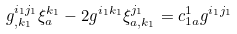Convert formula to latex. <formula><loc_0><loc_0><loc_500><loc_500>g ^ { i _ { 1 } j _ { 1 } } _ { , k _ { 1 } } \xi _ { a } ^ { k _ { 1 } } - 2 g ^ { i _ { 1 } k _ { 1 } } \xi _ { a , k _ { 1 } } ^ { j _ { 1 } } = c _ { 1 a } ^ { 1 } g ^ { i _ { 1 } j _ { 1 } }</formula> 